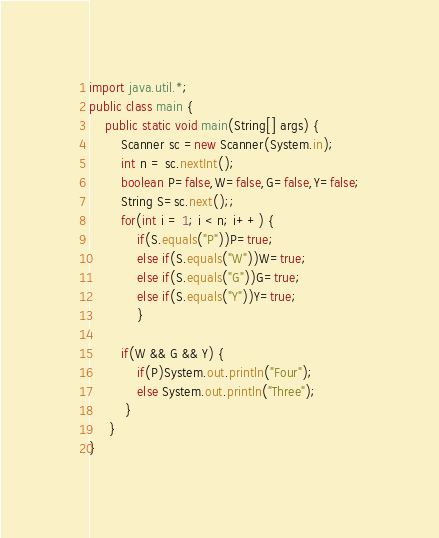Convert code to text. <code><loc_0><loc_0><loc_500><loc_500><_Java_>import java.util.*;
public class main {
	public static void main(String[] args) {
		Scanner sc =new Scanner(System.in);
		int n = sc.nextInt();
		boolean P=false,W=false,G=false,Y=false;
		String S=sc.next();;
		for(int i = 1; i < n; i++) {
			if(S.equals("P"))P=true;
			else if(S.equals("W"))W=true;
			else if(S.equals("G"))G=true;
			else if(S.equals("Y"))Y=true;
			}
		
		if(W && G && Y) {
			if(P)System.out.println("Four");
			else System.out.println("Three");
		 }
	 }
}</code> 